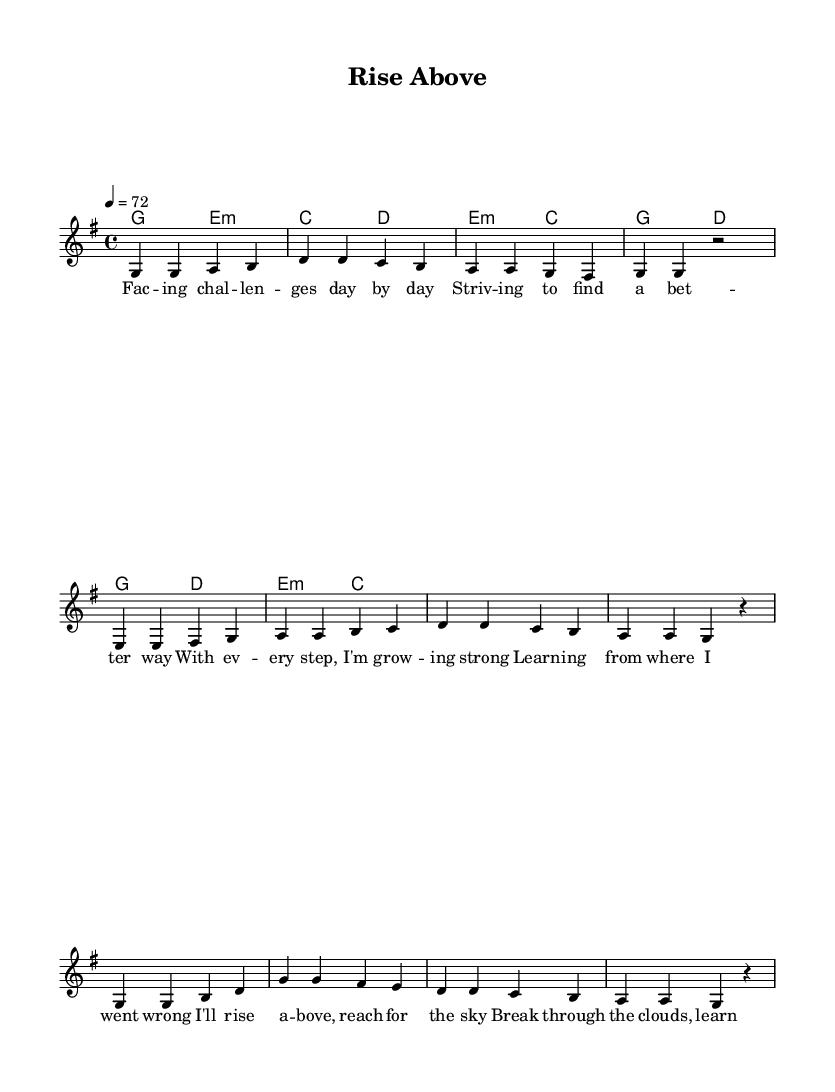What key is this piece in? The key signature shows one sharp, indicating that this piece is in G major.
Answer: G major What is the time signature of the music? The time signature displayed at the beginning indicates 4/4, meaning there are four beats in each measure.
Answer: 4/4 What is the tempo marking for the piece? The tempo marking indicates '4 = 72', which means there are 72 beats per minute.
Answer: 72 How many measures are there in the verse? The verse consists of 8 measures, as counted from the melody section of the sheet music.
Answer: 8 measures What is the first lyric of the song? The lyrics begin with "Fac--ing chal--len--ges day by day," which is the first line of the verse.
Answer: Facing challenges day by day Which lyrical section follows the verse? After the verse, the pre-chorus section follows, as indicated by the structure of the song.
Answer: Pre-Chorus In which section do we find the line "I'll rise above, reach for the sky"? This line appears in the verse section of the song, specifically near the end of the verse.
Answer: Verse 